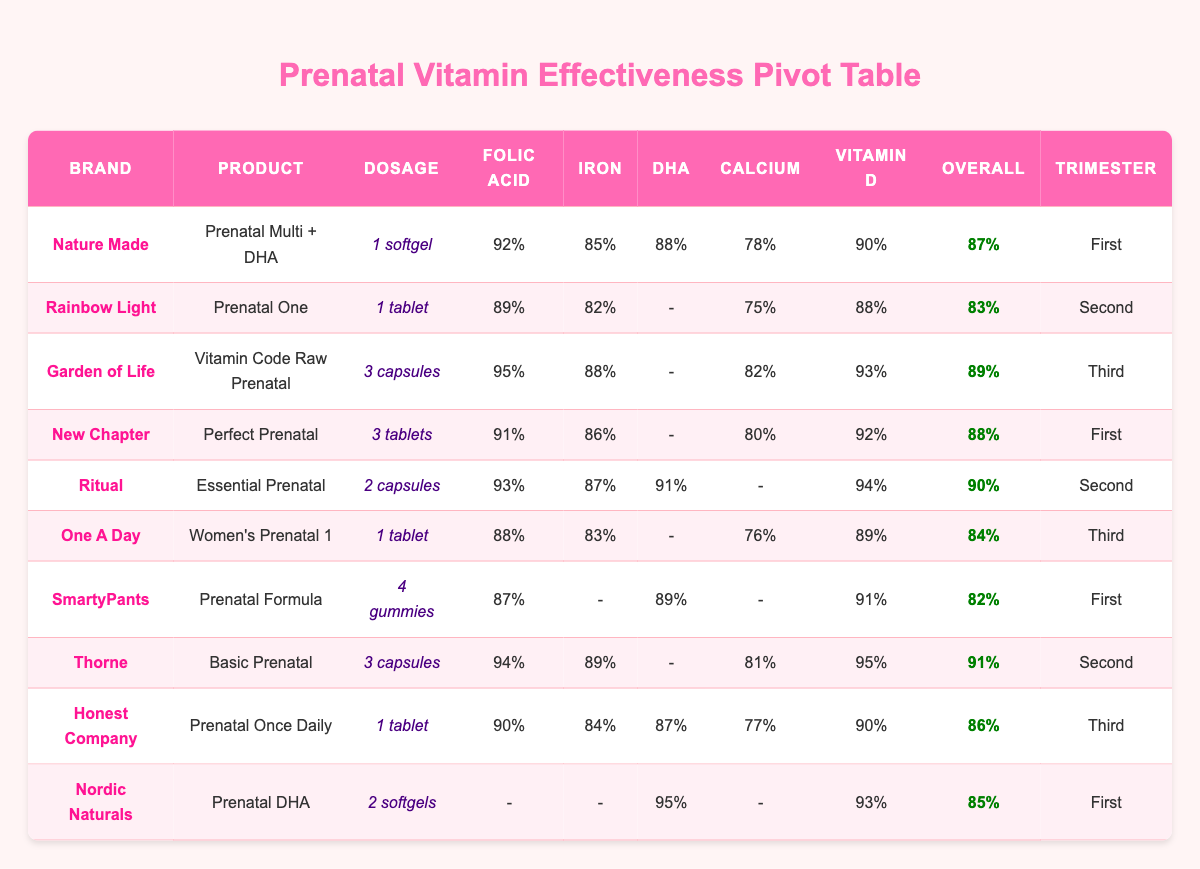What is the overall effectiveness of the "Ritual" prenatal vitamin? The table shows that "Ritual" under the product "Essential Prenatal" has an overall effectiveness of 90%.
Answer: 90% Which brand has the highest folic acid absorption rate? By reviewing the table, "Garden of Life" has the highest folic acid absorption rate of 95%.
Answer: 95% How many prenatal vitamins have an iron absorption rate above 85%? The table lists 5 prenatal vitamins with iron absorption rates above 85%: Nature Made (85%), Garden of Life (88%), New Chapter (86%), Ritual (87%), and Thorne (89%). So, the count is 5.
Answer: 5 Is the DHA absorption rate for "Nordic Naturals" low? "Nordic Naturals" has a DHA absorption rate of 95%, which is not considered low. So the answer is no.
Answer: No What is the average overall effectiveness of the prenatal vitamins in the second trimester? The overall effectiveness values for the second trimester vitamins are: Rainbow Light (83%), Ritual (90%), and Thorne (91%). Hence, the average is (83 + 90 + 91)/3 = 88.
Answer: 88 What is the big difference in calcium absorption between "Nature Made" and "Ritual"? "Nature Made" has a calcium absorption of 78% while "Ritual" has 0%, leading to a difference of 78%.
Answer: 78% Which product has the lowest calcium absorption rate? Looking through the table, "Ritual" has a calcium absorption rate of 0%, making it the lowest.
Answer: 0% Does "SmartyPants" have an iron absorption value present in the table? The table indicates that "SmartyPants" has an iron absorption value of 0%, which means there is no value present for iron absorption. So, the answer is yes.
Answer: Yes Which prenatal vitamin has the highest calcium absorption rate among the second trimester products? In the second trimester, the products are Rainbow Light (75%), Ritual (0%), and Thorne (81%). Among these, Thorne has the highest calcium absorption rate of 81%.
Answer: 81 